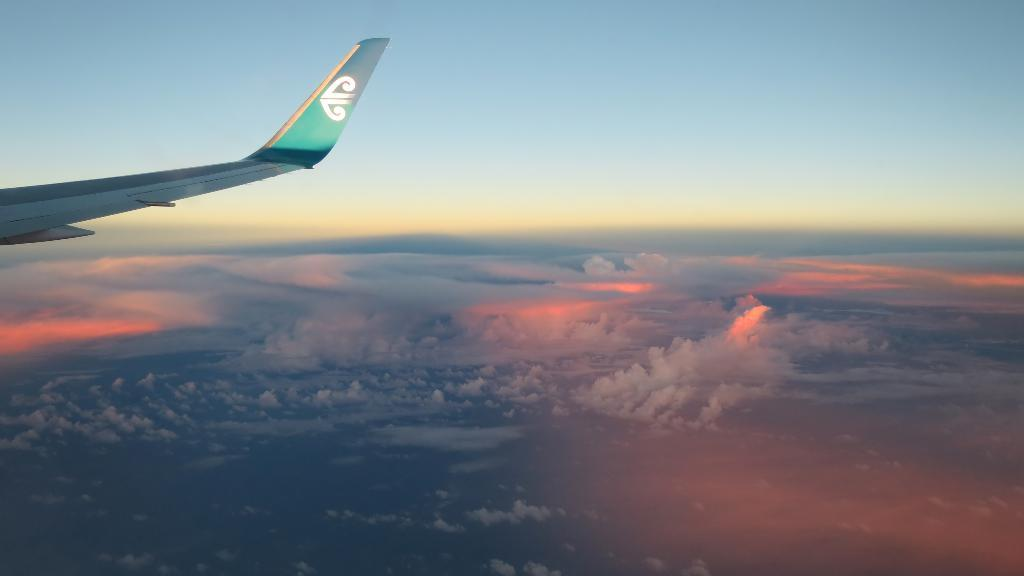What is the main subject of the image? The main subject of the image is an aeroplane wing. What can be seen in the background of the image? There are clouds and the sky visible in the background of the image. How many people are wearing skirts in the image? There are no people present in the image, so it is not possible to determine how many are wearing skirts. 